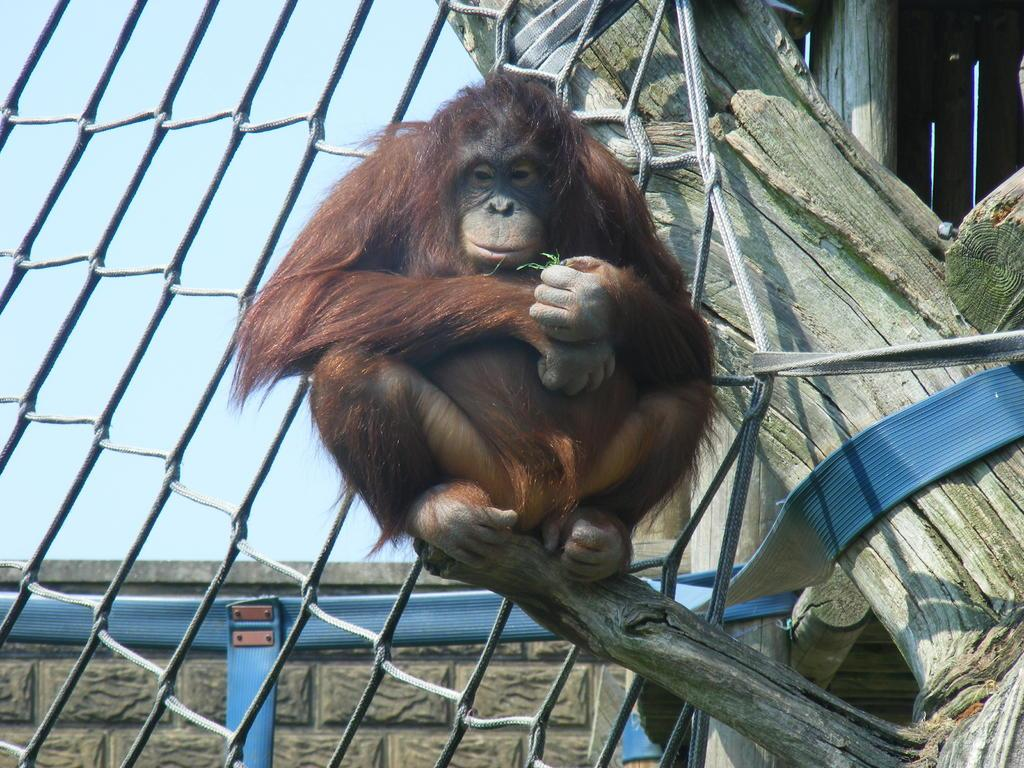What animal is in the image? There is a chimpanzee in the image. Where is the chimpanzee located? The chimpanzee is sitting on a tree branch. What type of fencing can be seen in the image? There is rope fencing in the image. What type of structure is visible in the image? There is a stone wall in the image. What can be seen in the background of the image? The sky is visible in the background of the image. What type of box is the chimpanzee using to frame the image? There is no box or framing device present in the image; it is a photograph of a chimpanzee sitting on a tree branch. 